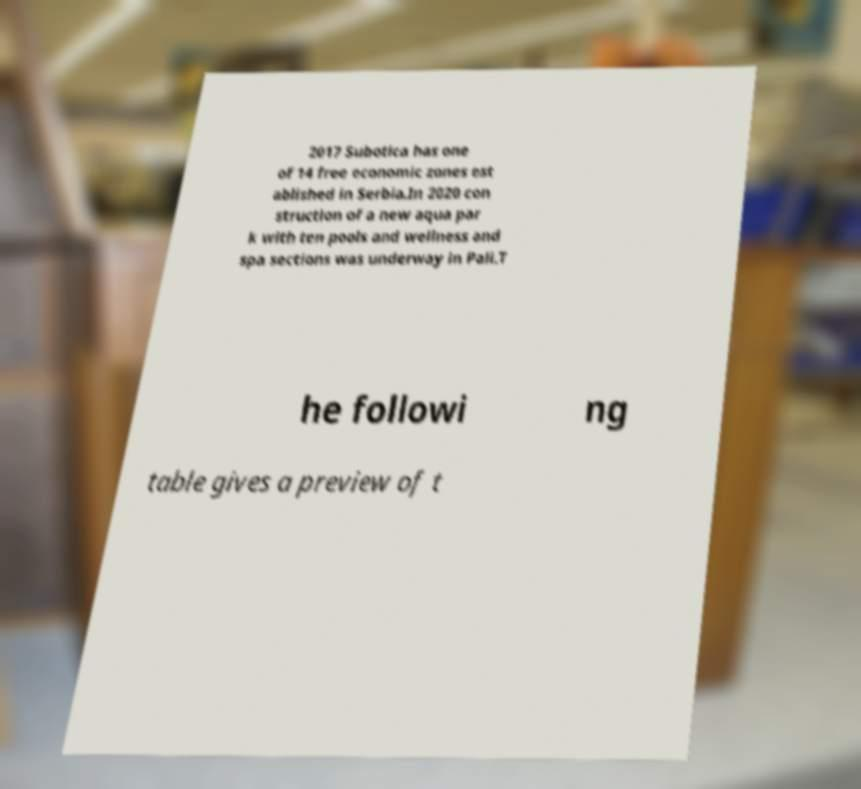I need the written content from this picture converted into text. Can you do that? 2017 Subotica has one of 14 free economic zones est ablished in Serbia.In 2020 con struction of a new aqua par k with ten pools and wellness and spa sections was underway in Pali.T he followi ng table gives a preview of t 